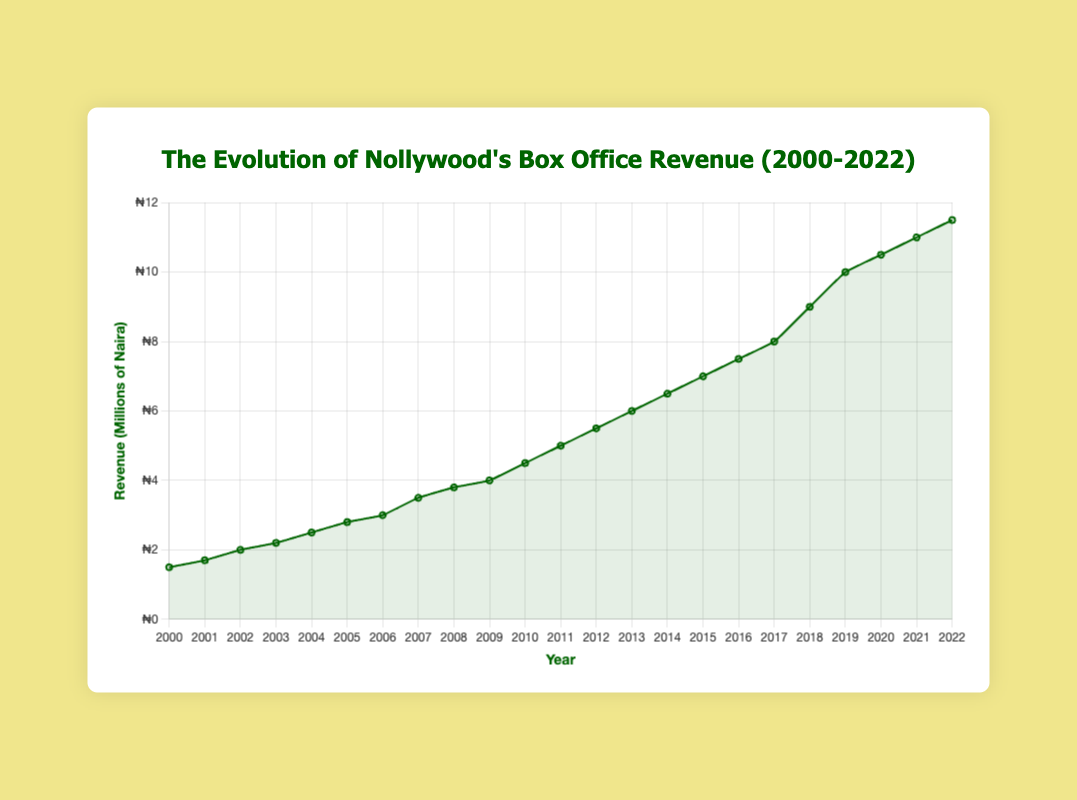How has Nollywood's box office revenue changed between 2000 and 2022? The figure shows the box office revenue for each year from 2000 to 2022. By examining the plot, we see that the box office revenue has consistently increased from ₦1.5 million in 2000 to ₦11.5 million in 2022.
Answer: Increased What was the box office revenue in 2015? To find the box office revenue for 2015, locate the year 2015 on the x-axis and refer to the corresponding y-axis value. The plot shows the box office revenue in 2015 as ₦7 million.
Answer: ₦7 million During which year did Nollywood see the largest increase in box office revenue? To determine the largest year-over-year increase, calculate the differences in box office revenue between each pair of consecutive years and find the maximum difference. The largest increase occurred between 2018 (₦9 million) and 2019 (₦10 million), a change of ₦1 million.
Answer: Between 2018 and 2019 What was the average box office revenue from 2000 to 2022? Add up all yearly revenues from 2000 to 2022 and divide by the number of years (23). The total is ₦121 million. The average is 121/23 ≈ ₦5.26 million.
Answer: ₦5.26 million By how much did the box office revenue change from 2007 to 2008? Look at the box office revenue for 2007 and 2008. The revenue in 2007 is ₦3.5 million, and in 2008 it is ₦3.8 million. The change is ₦3.8 million - ₦3.5 million = ₦0.3 million.
Answer: ₦0.3 million Was there any year where the box office revenue decreased compared to the previous year? Examine the plot for any downward slopes between consecutive years. There are no downward slopes, indicating that there was no year where the box office revenue decreased.
Answer: No Between 2010 and 2015, how much did the box office revenue increase in total? Find the box office revenue for 2010 and 2015, which are ₦4.5 million and ₦7 million respectively. The total increase is ₦7 million - ₦4.5 million = ₦2.5 million.
Answer: ₦2.5 million What is the percentage increase in box office revenue from 2000 to 2022? Calculate the percentage increase using the formula [(11.5 million - 1.5 million) / 1.5 million] * 100. The calculation gives [(10 million) / 1.5 million] * 100 ≈ 666.67%.
Answer: 666.67% Which year had the highest box office revenue? Identify the year corresponding to the highest point on the plot. The highest box office revenue is in 2022, with ₦11.5 million.
Answer: 2022 